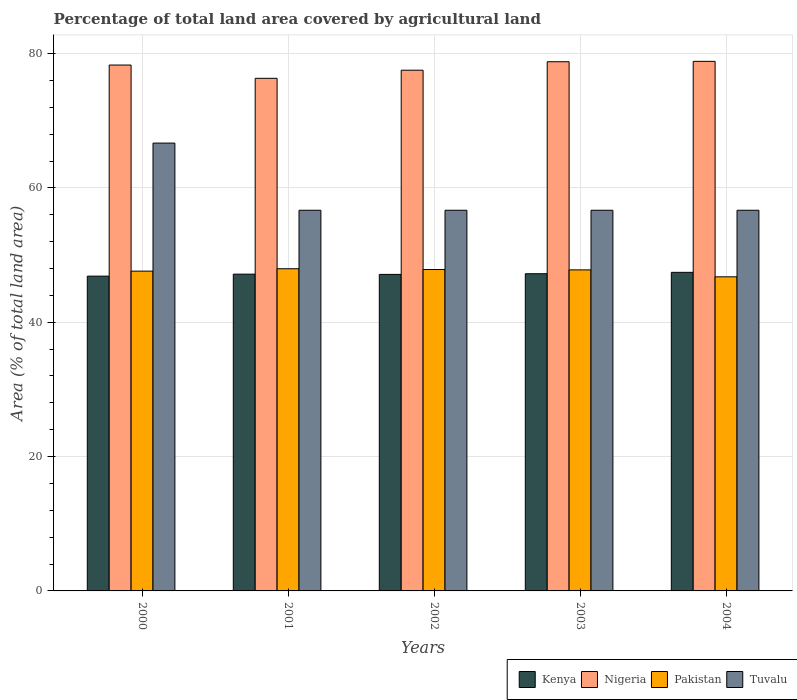How many groups of bars are there?
Provide a succinct answer. 5. Are the number of bars per tick equal to the number of legend labels?
Your answer should be very brief. Yes. How many bars are there on the 3rd tick from the left?
Your answer should be compact. 4. How many bars are there on the 2nd tick from the right?
Your answer should be compact. 4. What is the percentage of agricultural land in Pakistan in 2001?
Your answer should be very brief. 47.96. Across all years, what is the maximum percentage of agricultural land in Nigeria?
Your response must be concise. 78.83. Across all years, what is the minimum percentage of agricultural land in Tuvalu?
Offer a terse response. 56.67. In which year was the percentage of agricultural land in Kenya maximum?
Keep it short and to the point. 2004. In which year was the percentage of agricultural land in Nigeria minimum?
Provide a succinct answer. 2001. What is the total percentage of agricultural land in Pakistan in the graph?
Ensure brevity in your answer.  237.96. What is the difference between the percentage of agricultural land in Nigeria in 2002 and that in 2004?
Your answer should be very brief. -1.32. What is the difference between the percentage of agricultural land in Tuvalu in 2003 and the percentage of agricultural land in Pakistan in 2002?
Make the answer very short. 8.82. What is the average percentage of agricultural land in Nigeria per year?
Keep it short and to the point. 77.95. In the year 2002, what is the difference between the percentage of agricultural land in Kenya and percentage of agricultural land in Pakistan?
Your answer should be very brief. -0.73. In how many years, is the percentage of agricultural land in Pakistan greater than 48 %?
Your answer should be very brief. 0. What is the ratio of the percentage of agricultural land in Tuvalu in 2000 to that in 2002?
Offer a very short reply. 1.18. Is the difference between the percentage of agricultural land in Kenya in 2000 and 2001 greater than the difference between the percentage of agricultural land in Pakistan in 2000 and 2001?
Keep it short and to the point. Yes. What is the difference between the highest and the second highest percentage of agricultural land in Pakistan?
Offer a terse response. 0.11. What is the difference between the highest and the lowest percentage of agricultural land in Pakistan?
Provide a succinct answer. 1.2. In how many years, is the percentage of agricultural land in Nigeria greater than the average percentage of agricultural land in Nigeria taken over all years?
Your response must be concise. 3. Is it the case that in every year, the sum of the percentage of agricultural land in Nigeria and percentage of agricultural land in Pakistan is greater than the sum of percentage of agricultural land in Tuvalu and percentage of agricultural land in Kenya?
Keep it short and to the point. Yes. What does the 3rd bar from the left in 2002 represents?
Provide a short and direct response. Pakistan. What does the 1st bar from the right in 2003 represents?
Give a very brief answer. Tuvalu. How many bars are there?
Your response must be concise. 20. Are all the bars in the graph horizontal?
Your answer should be very brief. No. How many years are there in the graph?
Your answer should be compact. 5. Does the graph contain grids?
Ensure brevity in your answer.  Yes. Where does the legend appear in the graph?
Offer a very short reply. Bottom right. How many legend labels are there?
Offer a very short reply. 4. How are the legend labels stacked?
Your response must be concise. Horizontal. What is the title of the graph?
Provide a short and direct response. Percentage of total land area covered by agricultural land. Does "Italy" appear as one of the legend labels in the graph?
Ensure brevity in your answer.  No. What is the label or title of the X-axis?
Provide a short and direct response. Years. What is the label or title of the Y-axis?
Your answer should be very brief. Area (% of total land area). What is the Area (% of total land area) of Kenya in 2000?
Offer a terse response. 46.86. What is the Area (% of total land area) of Nigeria in 2000?
Ensure brevity in your answer.  78.29. What is the Area (% of total land area) in Pakistan in 2000?
Offer a very short reply. 47.61. What is the Area (% of total land area) in Tuvalu in 2000?
Make the answer very short. 66.67. What is the Area (% of total land area) in Kenya in 2001?
Your answer should be compact. 47.16. What is the Area (% of total land area) in Nigeria in 2001?
Provide a succinct answer. 76.31. What is the Area (% of total land area) in Pakistan in 2001?
Offer a very short reply. 47.96. What is the Area (% of total land area) of Tuvalu in 2001?
Keep it short and to the point. 56.67. What is the Area (% of total land area) of Kenya in 2002?
Your response must be concise. 47.12. What is the Area (% of total land area) of Nigeria in 2002?
Make the answer very short. 77.52. What is the Area (% of total land area) of Pakistan in 2002?
Keep it short and to the point. 47.85. What is the Area (% of total land area) of Tuvalu in 2002?
Give a very brief answer. 56.67. What is the Area (% of total land area) in Kenya in 2003?
Your answer should be very brief. 47.22. What is the Area (% of total land area) of Nigeria in 2003?
Provide a short and direct response. 78.78. What is the Area (% of total land area) of Pakistan in 2003?
Provide a short and direct response. 47.79. What is the Area (% of total land area) in Tuvalu in 2003?
Ensure brevity in your answer.  56.67. What is the Area (% of total land area) in Kenya in 2004?
Make the answer very short. 47.43. What is the Area (% of total land area) in Nigeria in 2004?
Keep it short and to the point. 78.83. What is the Area (% of total land area) in Pakistan in 2004?
Provide a short and direct response. 46.76. What is the Area (% of total land area) of Tuvalu in 2004?
Provide a short and direct response. 56.67. Across all years, what is the maximum Area (% of total land area) in Kenya?
Provide a succinct answer. 47.43. Across all years, what is the maximum Area (% of total land area) in Nigeria?
Offer a very short reply. 78.83. Across all years, what is the maximum Area (% of total land area) of Pakistan?
Provide a succinct answer. 47.96. Across all years, what is the maximum Area (% of total land area) in Tuvalu?
Your response must be concise. 66.67. Across all years, what is the minimum Area (% of total land area) in Kenya?
Your answer should be compact. 46.86. Across all years, what is the minimum Area (% of total land area) of Nigeria?
Give a very brief answer. 76.31. Across all years, what is the minimum Area (% of total land area) of Pakistan?
Ensure brevity in your answer.  46.76. Across all years, what is the minimum Area (% of total land area) of Tuvalu?
Your answer should be very brief. 56.67. What is the total Area (% of total land area) of Kenya in the graph?
Make the answer very short. 235.78. What is the total Area (% of total land area) of Nigeria in the graph?
Give a very brief answer. 389.73. What is the total Area (% of total land area) in Pakistan in the graph?
Your response must be concise. 237.96. What is the total Area (% of total land area) in Tuvalu in the graph?
Give a very brief answer. 293.33. What is the difference between the Area (% of total land area) in Kenya in 2000 and that in 2001?
Keep it short and to the point. -0.3. What is the difference between the Area (% of total land area) in Nigeria in 2000 and that in 2001?
Provide a succinct answer. 1.98. What is the difference between the Area (% of total land area) in Pakistan in 2000 and that in 2001?
Your answer should be compact. -0.36. What is the difference between the Area (% of total land area) of Kenya in 2000 and that in 2002?
Your response must be concise. -0.26. What is the difference between the Area (% of total land area) in Nigeria in 2000 and that in 2002?
Your answer should be compact. 0.77. What is the difference between the Area (% of total land area) in Pakistan in 2000 and that in 2002?
Provide a short and direct response. -0.24. What is the difference between the Area (% of total land area) of Kenya in 2000 and that in 2003?
Your answer should be compact. -0.36. What is the difference between the Area (% of total land area) of Nigeria in 2000 and that in 2003?
Your answer should be very brief. -0.49. What is the difference between the Area (% of total land area) in Pakistan in 2000 and that in 2003?
Give a very brief answer. -0.19. What is the difference between the Area (% of total land area) in Tuvalu in 2000 and that in 2003?
Your answer should be compact. 10. What is the difference between the Area (% of total land area) of Kenya in 2000 and that in 2004?
Provide a short and direct response. -0.56. What is the difference between the Area (% of total land area) of Nigeria in 2000 and that in 2004?
Provide a succinct answer. -0.55. What is the difference between the Area (% of total land area) in Pakistan in 2000 and that in 2004?
Keep it short and to the point. 0.85. What is the difference between the Area (% of total land area) in Tuvalu in 2000 and that in 2004?
Keep it short and to the point. 10. What is the difference between the Area (% of total land area) of Kenya in 2001 and that in 2002?
Provide a succinct answer. 0.04. What is the difference between the Area (% of total land area) in Nigeria in 2001 and that in 2002?
Your answer should be compact. -1.21. What is the difference between the Area (% of total land area) in Pakistan in 2001 and that in 2002?
Your answer should be very brief. 0.11. What is the difference between the Area (% of total land area) of Kenya in 2001 and that in 2003?
Offer a very short reply. -0.06. What is the difference between the Area (% of total land area) of Nigeria in 2001 and that in 2003?
Make the answer very short. -2.47. What is the difference between the Area (% of total land area) of Pakistan in 2001 and that in 2003?
Provide a succinct answer. 0.17. What is the difference between the Area (% of total land area) of Tuvalu in 2001 and that in 2003?
Ensure brevity in your answer.  0. What is the difference between the Area (% of total land area) of Kenya in 2001 and that in 2004?
Give a very brief answer. -0.27. What is the difference between the Area (% of total land area) of Nigeria in 2001 and that in 2004?
Give a very brief answer. -2.53. What is the difference between the Area (% of total land area) in Pakistan in 2001 and that in 2004?
Give a very brief answer. 1.2. What is the difference between the Area (% of total land area) in Tuvalu in 2001 and that in 2004?
Give a very brief answer. 0. What is the difference between the Area (% of total land area) of Kenya in 2002 and that in 2003?
Your response must be concise. -0.1. What is the difference between the Area (% of total land area) of Nigeria in 2002 and that in 2003?
Your answer should be compact. -1.26. What is the difference between the Area (% of total land area) in Pakistan in 2002 and that in 2003?
Keep it short and to the point. 0.05. What is the difference between the Area (% of total land area) in Tuvalu in 2002 and that in 2003?
Your answer should be compact. 0. What is the difference between the Area (% of total land area) of Kenya in 2002 and that in 2004?
Your answer should be compact. -0.31. What is the difference between the Area (% of total land area) in Nigeria in 2002 and that in 2004?
Offer a very short reply. -1.32. What is the difference between the Area (% of total land area) of Pakistan in 2002 and that in 2004?
Your answer should be compact. 1.09. What is the difference between the Area (% of total land area) in Tuvalu in 2002 and that in 2004?
Your response must be concise. 0. What is the difference between the Area (% of total land area) in Kenya in 2003 and that in 2004?
Give a very brief answer. -0.21. What is the difference between the Area (% of total land area) of Nigeria in 2003 and that in 2004?
Offer a terse response. -0.05. What is the difference between the Area (% of total land area) of Pakistan in 2003 and that in 2004?
Ensure brevity in your answer.  1.03. What is the difference between the Area (% of total land area) of Kenya in 2000 and the Area (% of total land area) of Nigeria in 2001?
Keep it short and to the point. -29.45. What is the difference between the Area (% of total land area) of Kenya in 2000 and the Area (% of total land area) of Pakistan in 2001?
Provide a short and direct response. -1.1. What is the difference between the Area (% of total land area) in Kenya in 2000 and the Area (% of total land area) in Tuvalu in 2001?
Offer a very short reply. -9.8. What is the difference between the Area (% of total land area) in Nigeria in 2000 and the Area (% of total land area) in Pakistan in 2001?
Ensure brevity in your answer.  30.32. What is the difference between the Area (% of total land area) in Nigeria in 2000 and the Area (% of total land area) in Tuvalu in 2001?
Provide a short and direct response. 21.62. What is the difference between the Area (% of total land area) of Pakistan in 2000 and the Area (% of total land area) of Tuvalu in 2001?
Your response must be concise. -9.06. What is the difference between the Area (% of total land area) of Kenya in 2000 and the Area (% of total land area) of Nigeria in 2002?
Make the answer very short. -30.65. What is the difference between the Area (% of total land area) of Kenya in 2000 and the Area (% of total land area) of Pakistan in 2002?
Your response must be concise. -0.98. What is the difference between the Area (% of total land area) in Kenya in 2000 and the Area (% of total land area) in Tuvalu in 2002?
Provide a short and direct response. -9.8. What is the difference between the Area (% of total land area) in Nigeria in 2000 and the Area (% of total land area) in Pakistan in 2002?
Your response must be concise. 30.44. What is the difference between the Area (% of total land area) in Nigeria in 2000 and the Area (% of total land area) in Tuvalu in 2002?
Offer a very short reply. 21.62. What is the difference between the Area (% of total land area) in Pakistan in 2000 and the Area (% of total land area) in Tuvalu in 2002?
Ensure brevity in your answer.  -9.06. What is the difference between the Area (% of total land area) in Kenya in 2000 and the Area (% of total land area) in Nigeria in 2003?
Provide a succinct answer. -31.92. What is the difference between the Area (% of total land area) in Kenya in 2000 and the Area (% of total land area) in Pakistan in 2003?
Ensure brevity in your answer.  -0.93. What is the difference between the Area (% of total land area) of Kenya in 2000 and the Area (% of total land area) of Tuvalu in 2003?
Offer a very short reply. -9.8. What is the difference between the Area (% of total land area) of Nigeria in 2000 and the Area (% of total land area) of Pakistan in 2003?
Provide a short and direct response. 30.49. What is the difference between the Area (% of total land area) of Nigeria in 2000 and the Area (% of total land area) of Tuvalu in 2003?
Keep it short and to the point. 21.62. What is the difference between the Area (% of total land area) of Pakistan in 2000 and the Area (% of total land area) of Tuvalu in 2003?
Offer a terse response. -9.06. What is the difference between the Area (% of total land area) of Kenya in 2000 and the Area (% of total land area) of Nigeria in 2004?
Offer a terse response. -31.97. What is the difference between the Area (% of total land area) of Kenya in 2000 and the Area (% of total land area) of Pakistan in 2004?
Keep it short and to the point. 0.1. What is the difference between the Area (% of total land area) in Kenya in 2000 and the Area (% of total land area) in Tuvalu in 2004?
Your answer should be compact. -9.8. What is the difference between the Area (% of total land area) in Nigeria in 2000 and the Area (% of total land area) in Pakistan in 2004?
Your answer should be very brief. 31.53. What is the difference between the Area (% of total land area) of Nigeria in 2000 and the Area (% of total land area) of Tuvalu in 2004?
Ensure brevity in your answer.  21.62. What is the difference between the Area (% of total land area) in Pakistan in 2000 and the Area (% of total land area) in Tuvalu in 2004?
Give a very brief answer. -9.06. What is the difference between the Area (% of total land area) of Kenya in 2001 and the Area (% of total land area) of Nigeria in 2002?
Your answer should be compact. -30.36. What is the difference between the Area (% of total land area) of Kenya in 2001 and the Area (% of total land area) of Pakistan in 2002?
Your response must be concise. -0.69. What is the difference between the Area (% of total land area) of Kenya in 2001 and the Area (% of total land area) of Tuvalu in 2002?
Provide a short and direct response. -9.51. What is the difference between the Area (% of total land area) of Nigeria in 2001 and the Area (% of total land area) of Pakistan in 2002?
Your response must be concise. 28.46. What is the difference between the Area (% of total land area) in Nigeria in 2001 and the Area (% of total land area) in Tuvalu in 2002?
Keep it short and to the point. 19.64. What is the difference between the Area (% of total land area) in Pakistan in 2001 and the Area (% of total land area) in Tuvalu in 2002?
Offer a very short reply. -8.71. What is the difference between the Area (% of total land area) in Kenya in 2001 and the Area (% of total land area) in Nigeria in 2003?
Your answer should be compact. -31.62. What is the difference between the Area (% of total land area) of Kenya in 2001 and the Area (% of total land area) of Pakistan in 2003?
Ensure brevity in your answer.  -0.64. What is the difference between the Area (% of total land area) of Kenya in 2001 and the Area (% of total land area) of Tuvalu in 2003?
Provide a short and direct response. -9.51. What is the difference between the Area (% of total land area) of Nigeria in 2001 and the Area (% of total land area) of Pakistan in 2003?
Keep it short and to the point. 28.52. What is the difference between the Area (% of total land area) in Nigeria in 2001 and the Area (% of total land area) in Tuvalu in 2003?
Keep it short and to the point. 19.64. What is the difference between the Area (% of total land area) of Pakistan in 2001 and the Area (% of total land area) of Tuvalu in 2003?
Your response must be concise. -8.71. What is the difference between the Area (% of total land area) in Kenya in 2001 and the Area (% of total land area) in Nigeria in 2004?
Keep it short and to the point. -31.68. What is the difference between the Area (% of total land area) in Kenya in 2001 and the Area (% of total land area) in Pakistan in 2004?
Offer a terse response. 0.4. What is the difference between the Area (% of total land area) of Kenya in 2001 and the Area (% of total land area) of Tuvalu in 2004?
Provide a short and direct response. -9.51. What is the difference between the Area (% of total land area) of Nigeria in 2001 and the Area (% of total land area) of Pakistan in 2004?
Ensure brevity in your answer.  29.55. What is the difference between the Area (% of total land area) in Nigeria in 2001 and the Area (% of total land area) in Tuvalu in 2004?
Offer a terse response. 19.64. What is the difference between the Area (% of total land area) in Pakistan in 2001 and the Area (% of total land area) in Tuvalu in 2004?
Give a very brief answer. -8.71. What is the difference between the Area (% of total land area) of Kenya in 2002 and the Area (% of total land area) of Nigeria in 2003?
Offer a very short reply. -31.66. What is the difference between the Area (% of total land area) of Kenya in 2002 and the Area (% of total land area) of Pakistan in 2003?
Keep it short and to the point. -0.67. What is the difference between the Area (% of total land area) of Kenya in 2002 and the Area (% of total land area) of Tuvalu in 2003?
Give a very brief answer. -9.55. What is the difference between the Area (% of total land area) of Nigeria in 2002 and the Area (% of total land area) of Pakistan in 2003?
Your answer should be compact. 29.72. What is the difference between the Area (% of total land area) of Nigeria in 2002 and the Area (% of total land area) of Tuvalu in 2003?
Offer a very short reply. 20.85. What is the difference between the Area (% of total land area) of Pakistan in 2002 and the Area (% of total land area) of Tuvalu in 2003?
Make the answer very short. -8.82. What is the difference between the Area (% of total land area) of Kenya in 2002 and the Area (% of total land area) of Nigeria in 2004?
Your answer should be very brief. -31.71. What is the difference between the Area (% of total land area) of Kenya in 2002 and the Area (% of total land area) of Pakistan in 2004?
Your response must be concise. 0.36. What is the difference between the Area (% of total land area) of Kenya in 2002 and the Area (% of total land area) of Tuvalu in 2004?
Your answer should be very brief. -9.55. What is the difference between the Area (% of total land area) of Nigeria in 2002 and the Area (% of total land area) of Pakistan in 2004?
Provide a short and direct response. 30.76. What is the difference between the Area (% of total land area) in Nigeria in 2002 and the Area (% of total land area) in Tuvalu in 2004?
Keep it short and to the point. 20.85. What is the difference between the Area (% of total land area) of Pakistan in 2002 and the Area (% of total land area) of Tuvalu in 2004?
Make the answer very short. -8.82. What is the difference between the Area (% of total land area) in Kenya in 2003 and the Area (% of total land area) in Nigeria in 2004?
Provide a short and direct response. -31.62. What is the difference between the Area (% of total land area) of Kenya in 2003 and the Area (% of total land area) of Pakistan in 2004?
Offer a terse response. 0.46. What is the difference between the Area (% of total land area) of Kenya in 2003 and the Area (% of total land area) of Tuvalu in 2004?
Your answer should be very brief. -9.45. What is the difference between the Area (% of total land area) in Nigeria in 2003 and the Area (% of total land area) in Pakistan in 2004?
Make the answer very short. 32.02. What is the difference between the Area (% of total land area) in Nigeria in 2003 and the Area (% of total land area) in Tuvalu in 2004?
Your answer should be very brief. 22.11. What is the difference between the Area (% of total land area) of Pakistan in 2003 and the Area (% of total land area) of Tuvalu in 2004?
Ensure brevity in your answer.  -8.87. What is the average Area (% of total land area) in Kenya per year?
Make the answer very short. 47.16. What is the average Area (% of total land area) in Nigeria per year?
Your answer should be compact. 77.94. What is the average Area (% of total land area) of Pakistan per year?
Ensure brevity in your answer.  47.59. What is the average Area (% of total land area) of Tuvalu per year?
Your answer should be very brief. 58.67. In the year 2000, what is the difference between the Area (% of total land area) in Kenya and Area (% of total land area) in Nigeria?
Offer a very short reply. -31.42. In the year 2000, what is the difference between the Area (% of total land area) in Kenya and Area (% of total land area) in Pakistan?
Offer a terse response. -0.74. In the year 2000, what is the difference between the Area (% of total land area) in Kenya and Area (% of total land area) in Tuvalu?
Ensure brevity in your answer.  -19.8. In the year 2000, what is the difference between the Area (% of total land area) in Nigeria and Area (% of total land area) in Pakistan?
Make the answer very short. 30.68. In the year 2000, what is the difference between the Area (% of total land area) of Nigeria and Area (% of total land area) of Tuvalu?
Offer a very short reply. 11.62. In the year 2000, what is the difference between the Area (% of total land area) of Pakistan and Area (% of total land area) of Tuvalu?
Keep it short and to the point. -19.06. In the year 2001, what is the difference between the Area (% of total land area) of Kenya and Area (% of total land area) of Nigeria?
Provide a short and direct response. -29.15. In the year 2001, what is the difference between the Area (% of total land area) of Kenya and Area (% of total land area) of Pakistan?
Provide a succinct answer. -0.8. In the year 2001, what is the difference between the Area (% of total land area) in Kenya and Area (% of total land area) in Tuvalu?
Make the answer very short. -9.51. In the year 2001, what is the difference between the Area (% of total land area) in Nigeria and Area (% of total land area) in Pakistan?
Provide a succinct answer. 28.35. In the year 2001, what is the difference between the Area (% of total land area) of Nigeria and Area (% of total land area) of Tuvalu?
Ensure brevity in your answer.  19.64. In the year 2001, what is the difference between the Area (% of total land area) of Pakistan and Area (% of total land area) of Tuvalu?
Make the answer very short. -8.71. In the year 2002, what is the difference between the Area (% of total land area) in Kenya and Area (% of total land area) in Nigeria?
Your response must be concise. -30.4. In the year 2002, what is the difference between the Area (% of total land area) in Kenya and Area (% of total land area) in Pakistan?
Keep it short and to the point. -0.73. In the year 2002, what is the difference between the Area (% of total land area) of Kenya and Area (% of total land area) of Tuvalu?
Provide a succinct answer. -9.55. In the year 2002, what is the difference between the Area (% of total land area) in Nigeria and Area (% of total land area) in Pakistan?
Provide a succinct answer. 29.67. In the year 2002, what is the difference between the Area (% of total land area) of Nigeria and Area (% of total land area) of Tuvalu?
Provide a short and direct response. 20.85. In the year 2002, what is the difference between the Area (% of total land area) of Pakistan and Area (% of total land area) of Tuvalu?
Your response must be concise. -8.82. In the year 2003, what is the difference between the Area (% of total land area) in Kenya and Area (% of total land area) in Nigeria?
Your answer should be very brief. -31.56. In the year 2003, what is the difference between the Area (% of total land area) of Kenya and Area (% of total land area) of Pakistan?
Provide a short and direct response. -0.57. In the year 2003, what is the difference between the Area (% of total land area) in Kenya and Area (% of total land area) in Tuvalu?
Keep it short and to the point. -9.45. In the year 2003, what is the difference between the Area (% of total land area) of Nigeria and Area (% of total land area) of Pakistan?
Your answer should be very brief. 30.99. In the year 2003, what is the difference between the Area (% of total land area) in Nigeria and Area (% of total land area) in Tuvalu?
Provide a short and direct response. 22.11. In the year 2003, what is the difference between the Area (% of total land area) of Pakistan and Area (% of total land area) of Tuvalu?
Make the answer very short. -8.87. In the year 2004, what is the difference between the Area (% of total land area) in Kenya and Area (% of total land area) in Nigeria?
Offer a very short reply. -31.41. In the year 2004, what is the difference between the Area (% of total land area) of Kenya and Area (% of total land area) of Pakistan?
Your response must be concise. 0.67. In the year 2004, what is the difference between the Area (% of total land area) of Kenya and Area (% of total land area) of Tuvalu?
Provide a succinct answer. -9.24. In the year 2004, what is the difference between the Area (% of total land area) in Nigeria and Area (% of total land area) in Pakistan?
Your response must be concise. 32.08. In the year 2004, what is the difference between the Area (% of total land area) of Nigeria and Area (% of total land area) of Tuvalu?
Ensure brevity in your answer.  22.17. In the year 2004, what is the difference between the Area (% of total land area) of Pakistan and Area (% of total land area) of Tuvalu?
Offer a terse response. -9.91. What is the ratio of the Area (% of total land area) of Kenya in 2000 to that in 2001?
Your response must be concise. 0.99. What is the ratio of the Area (% of total land area) in Nigeria in 2000 to that in 2001?
Your answer should be very brief. 1.03. What is the ratio of the Area (% of total land area) of Tuvalu in 2000 to that in 2001?
Your answer should be compact. 1.18. What is the ratio of the Area (% of total land area) in Nigeria in 2000 to that in 2002?
Ensure brevity in your answer.  1.01. What is the ratio of the Area (% of total land area) in Tuvalu in 2000 to that in 2002?
Give a very brief answer. 1.18. What is the ratio of the Area (% of total land area) of Kenya in 2000 to that in 2003?
Offer a very short reply. 0.99. What is the ratio of the Area (% of total land area) of Pakistan in 2000 to that in 2003?
Your answer should be compact. 1. What is the ratio of the Area (% of total land area) of Tuvalu in 2000 to that in 2003?
Give a very brief answer. 1.18. What is the ratio of the Area (% of total land area) in Kenya in 2000 to that in 2004?
Your answer should be very brief. 0.99. What is the ratio of the Area (% of total land area) in Nigeria in 2000 to that in 2004?
Keep it short and to the point. 0.99. What is the ratio of the Area (% of total land area) of Pakistan in 2000 to that in 2004?
Make the answer very short. 1.02. What is the ratio of the Area (% of total land area) in Tuvalu in 2000 to that in 2004?
Provide a short and direct response. 1.18. What is the ratio of the Area (% of total land area) in Nigeria in 2001 to that in 2002?
Your answer should be compact. 0.98. What is the ratio of the Area (% of total land area) of Tuvalu in 2001 to that in 2002?
Offer a terse response. 1. What is the ratio of the Area (% of total land area) of Kenya in 2001 to that in 2003?
Keep it short and to the point. 1. What is the ratio of the Area (% of total land area) in Nigeria in 2001 to that in 2003?
Provide a short and direct response. 0.97. What is the ratio of the Area (% of total land area) in Pakistan in 2001 to that in 2003?
Offer a terse response. 1. What is the ratio of the Area (% of total land area) of Kenya in 2001 to that in 2004?
Offer a very short reply. 0.99. What is the ratio of the Area (% of total land area) of Pakistan in 2001 to that in 2004?
Offer a very short reply. 1.03. What is the ratio of the Area (% of total land area) in Kenya in 2002 to that in 2003?
Offer a very short reply. 1. What is the ratio of the Area (% of total land area) of Kenya in 2002 to that in 2004?
Offer a terse response. 0.99. What is the ratio of the Area (% of total land area) in Nigeria in 2002 to that in 2004?
Provide a short and direct response. 0.98. What is the ratio of the Area (% of total land area) in Pakistan in 2002 to that in 2004?
Offer a terse response. 1.02. What is the ratio of the Area (% of total land area) of Nigeria in 2003 to that in 2004?
Your answer should be very brief. 1. What is the ratio of the Area (% of total land area) in Pakistan in 2003 to that in 2004?
Your answer should be very brief. 1.02. What is the difference between the highest and the second highest Area (% of total land area) in Kenya?
Keep it short and to the point. 0.21. What is the difference between the highest and the second highest Area (% of total land area) of Nigeria?
Your response must be concise. 0.05. What is the difference between the highest and the second highest Area (% of total land area) in Pakistan?
Keep it short and to the point. 0.11. What is the difference between the highest and the second highest Area (% of total land area) of Tuvalu?
Provide a short and direct response. 10. What is the difference between the highest and the lowest Area (% of total land area) in Kenya?
Make the answer very short. 0.56. What is the difference between the highest and the lowest Area (% of total land area) of Nigeria?
Provide a succinct answer. 2.53. What is the difference between the highest and the lowest Area (% of total land area) in Pakistan?
Make the answer very short. 1.2. What is the difference between the highest and the lowest Area (% of total land area) of Tuvalu?
Offer a terse response. 10. 